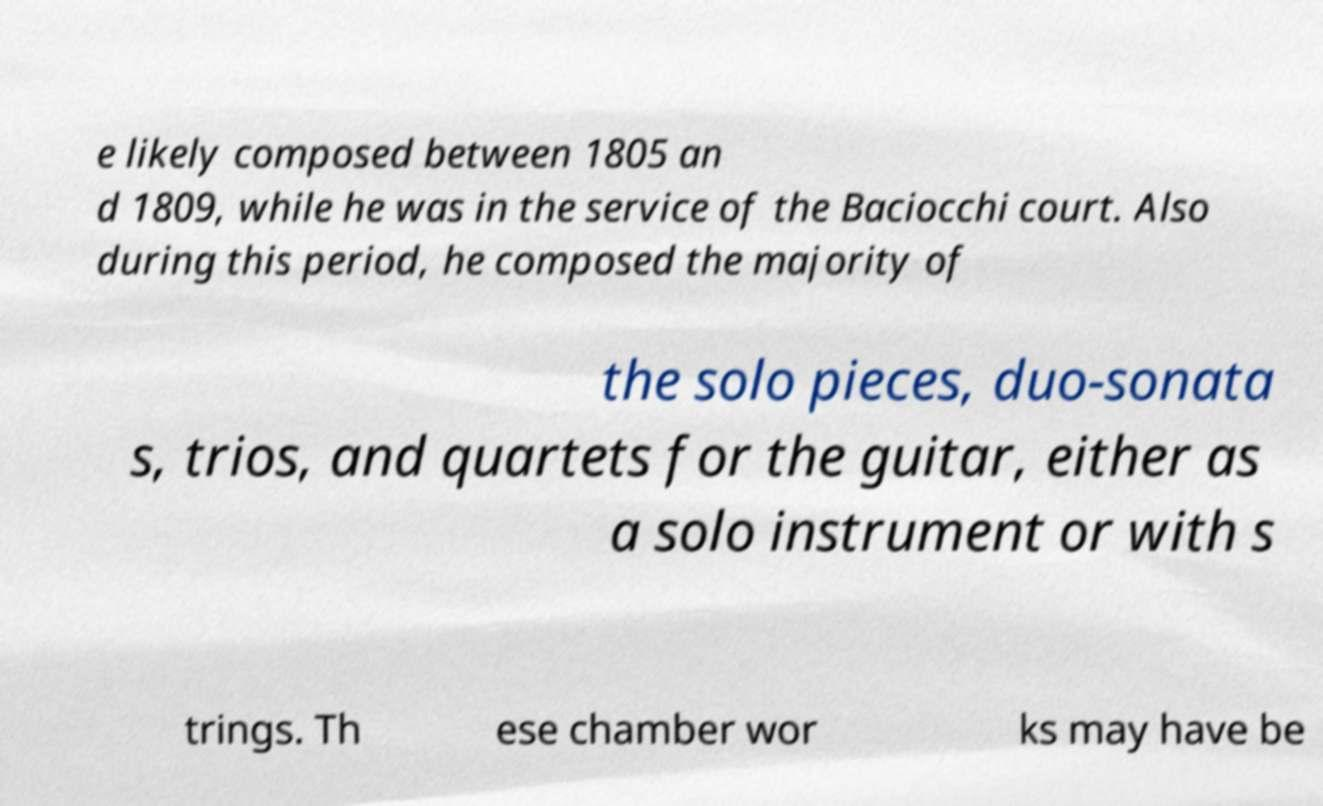Please identify and transcribe the text found in this image. e likely composed between 1805 an d 1809, while he was in the service of the Baciocchi court. Also during this period, he composed the majority of the solo pieces, duo-sonata s, trios, and quartets for the guitar, either as a solo instrument or with s trings. Th ese chamber wor ks may have be 